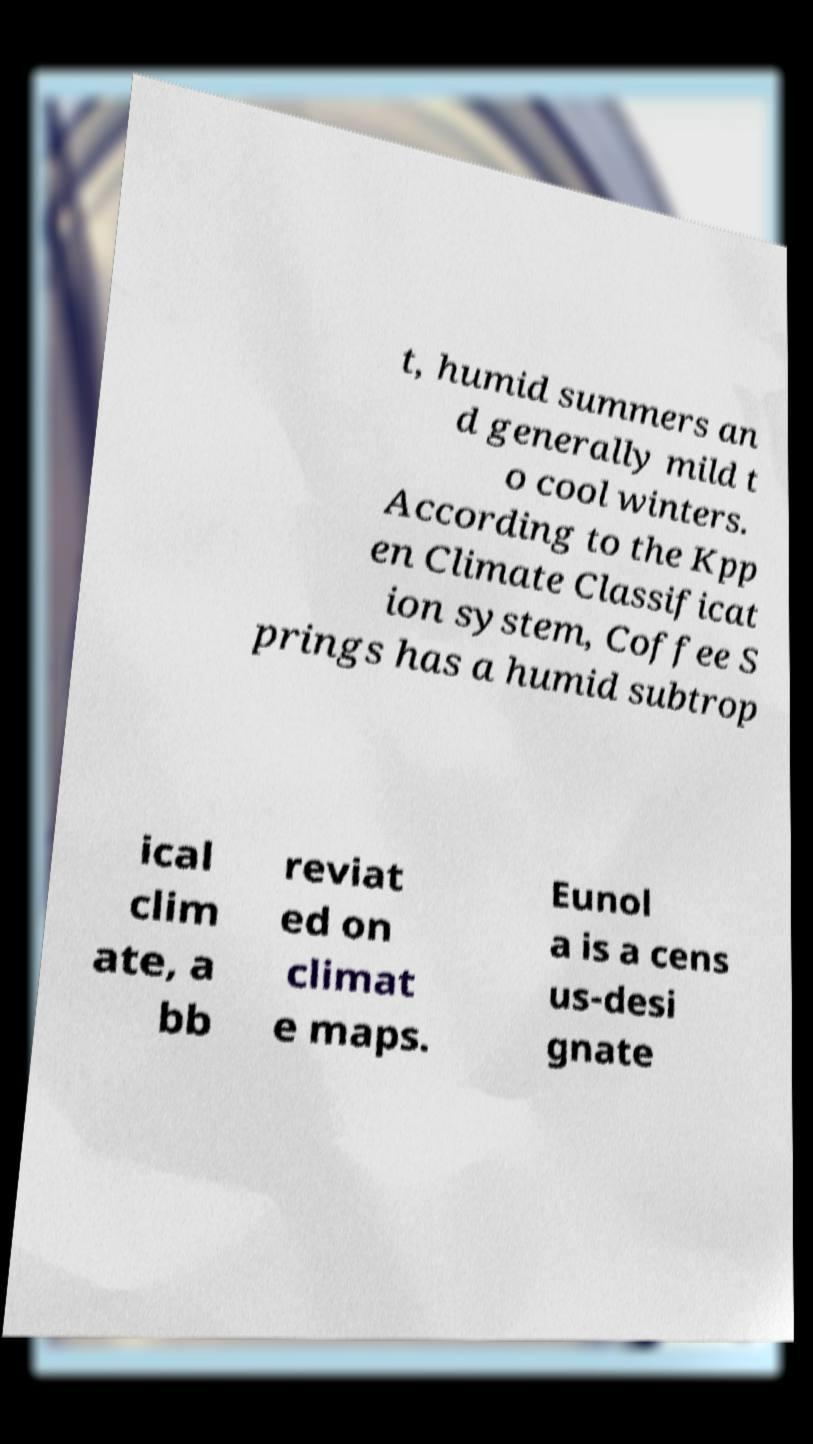Can you read and provide the text displayed in the image?This photo seems to have some interesting text. Can you extract and type it out for me? t, humid summers an d generally mild t o cool winters. According to the Kpp en Climate Classificat ion system, Coffee S prings has a humid subtrop ical clim ate, a bb reviat ed on climat e maps. Eunol a is a cens us-desi gnate 